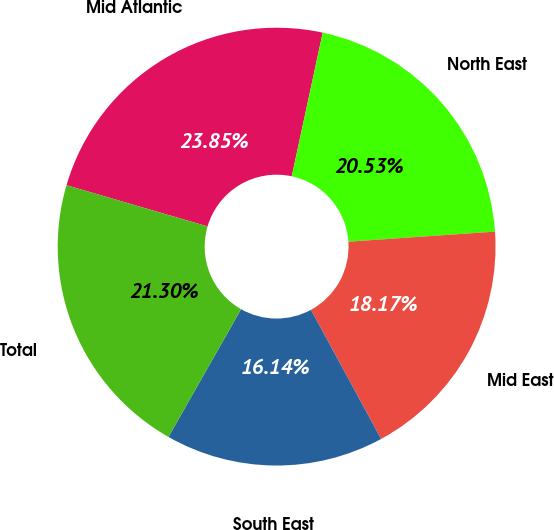Convert chart. <chart><loc_0><loc_0><loc_500><loc_500><pie_chart><fcel>Mid Atlantic<fcel>North East<fcel>Mid East<fcel>South East<fcel>Total<nl><fcel>23.85%<fcel>20.53%<fcel>18.17%<fcel>16.14%<fcel>21.3%<nl></chart> 